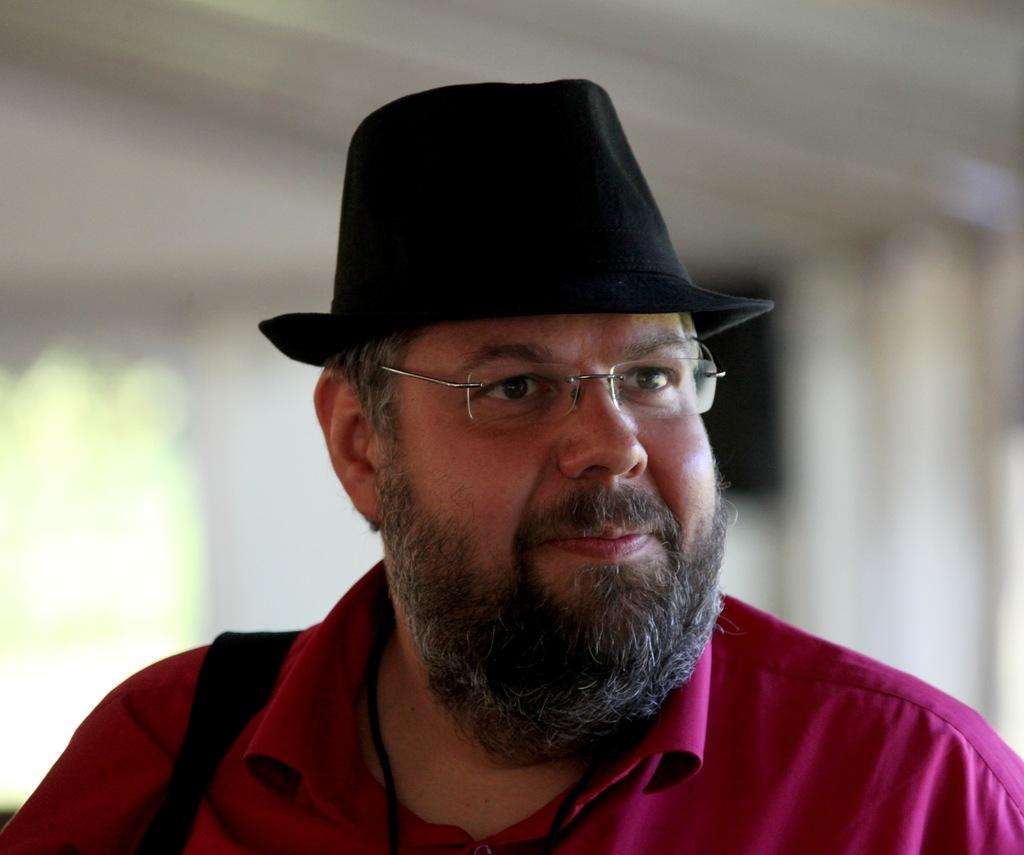What can be seen in the image? There is a person in the image. Can you describe the person's appearance? The person is wearing spectacles and a cap. What can be observed about the background of the image? The background of the image is blurry. Is the person in the image stuck in quicksand? There is no quicksand present in the image, and the person is not shown to be stuck in any substance. 